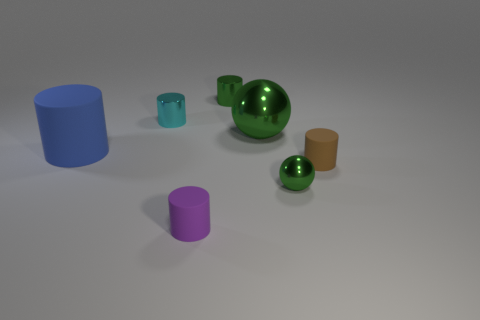Does the small cylinder that is on the right side of the large sphere have the same color as the large thing to the right of the tiny purple matte thing?
Keep it short and to the point. No. How many matte objects are big cylinders or large objects?
Keep it short and to the point. 1. How many small matte cylinders are in front of the green shiny sphere that is behind the tiny metallic object that is in front of the large cylinder?
Make the answer very short. 2. The other ball that is the same material as the tiny green sphere is what size?
Provide a succinct answer. Large. What number of small metallic cylinders are the same color as the big rubber object?
Your answer should be compact. 0. There is a shiny thing that is left of the purple cylinder; is it the same size as the green shiny cylinder?
Ensure brevity in your answer.  Yes. What is the color of the thing that is both right of the green cylinder and behind the large rubber cylinder?
Provide a succinct answer. Green. What number of things are either small cyan things or tiny shiny things that are in front of the small brown thing?
Your response must be concise. 2. There is a tiny cyan object in front of the small green object that is behind the green metal object that is in front of the large green thing; what is its material?
Offer a terse response. Metal. Is there anything else that is the same material as the brown cylinder?
Your answer should be compact. Yes. 